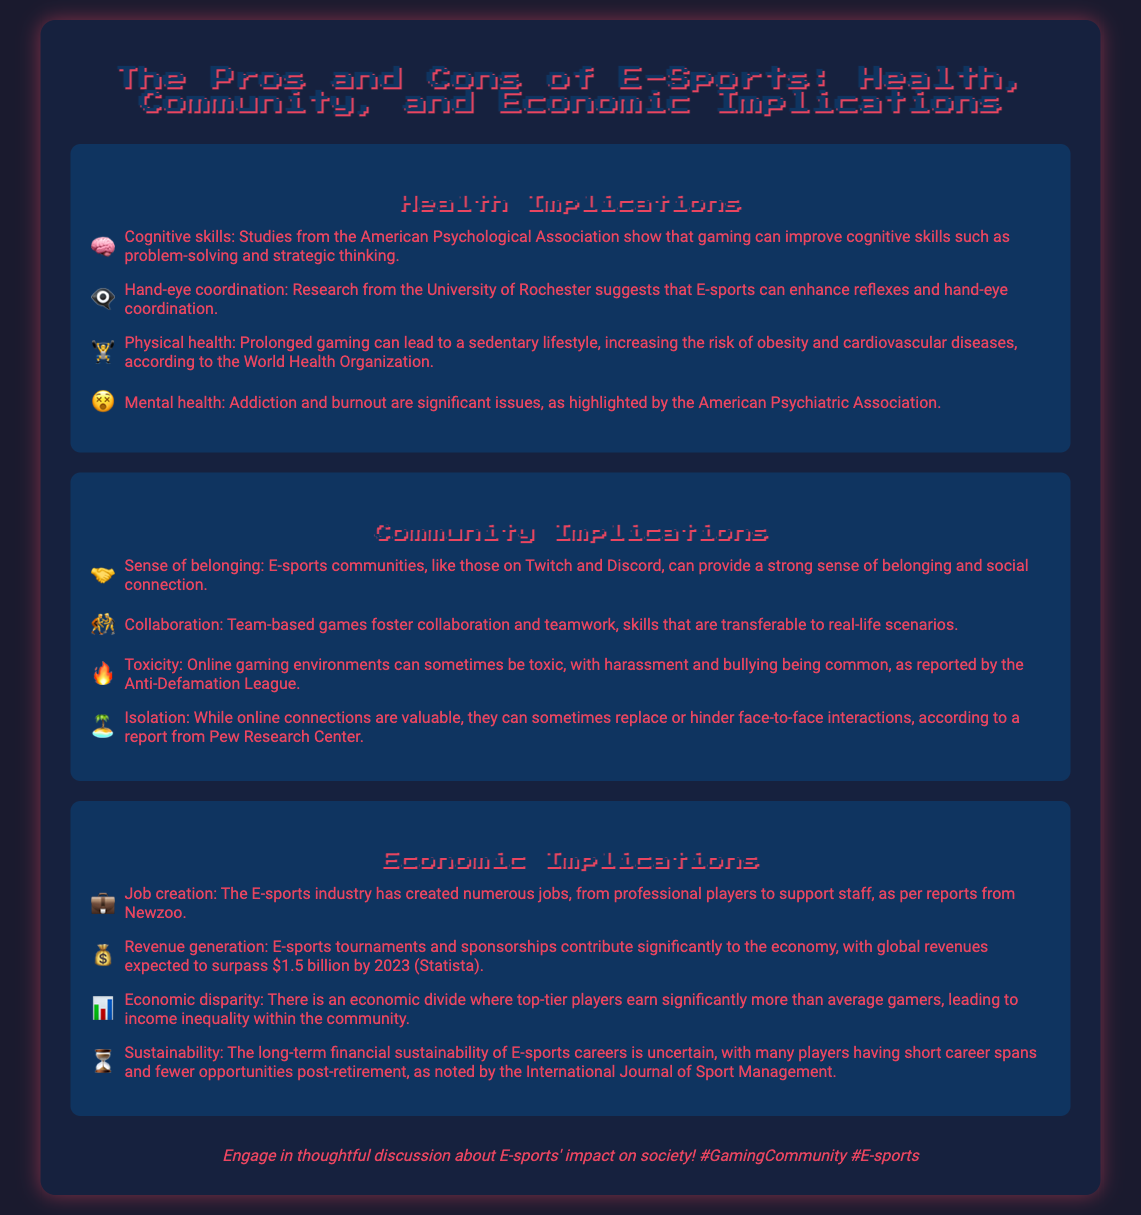What are the benefits of gaming for cognitive skills? The document highlights that studies from the American Psychological Association show that gaming can improve cognitive skills such as problem-solving and strategic thinking.
Answer: Cognitive skills What does research from the University of Rochester suggest about E-sports? The research suggests that E-sports can enhance reflexes and hand-eye coordination.
Answer: Hand-eye coordination What significant issues related to mental health are highlighted? The document mentions addiction and burnout as significant issues highlighted by the American Psychiatric Association.
Answer: Addiction and burnout Which online platforms provide a sense of belonging in E-sports communities? The document specifies platforms like Twitch and Discord that provide a strong sense of belonging and social connection.
Answer: Twitch and Discord What economic contribution do E-sports tournaments and sponsorships make? The document states that they contribute significantly to the economy, with global revenues expected to surpass $1.5 billion by 2023 according to Statista.
Answer: $1.5 billion What issue is pointed out regarding economic disparity in E-sports? The document addresses the economic divide where top-tier players earn significantly more than average gamers, leading to income inequality.
Answer: Income inequality Which organization reports on the uncertainty of financial sustainability in E-sports careers? The document notes that the International Journal of Sport Management has mentioned the uncertainty of long-term financial sustainability of E-sports careers.
Answer: International Journal of Sport Management What is a drawback of online gaming environments mentioned? The document mentions that online gaming can sometimes be toxic, with harassment and bullying being common, as reported by the Anti-Defamation League.
Answer: Toxicity What skill is fostered through collaboration in team-based games? The document states that collaboration in team-based games fosters teamwork, which is a skill transferable to real-life scenarios.
Answer: Teamwork 